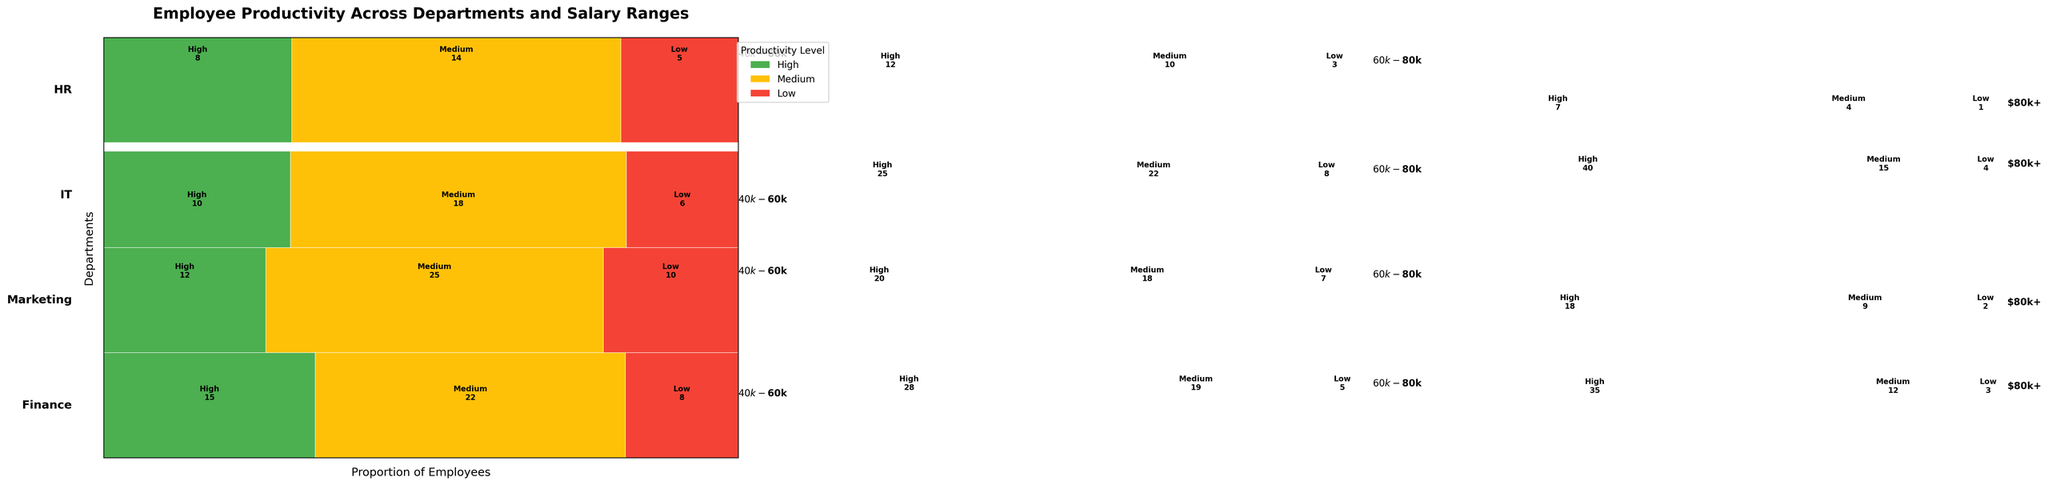What are the salary ranges displayed in the mosaic plot? The salary ranges are displayed as part of the labels within the plot for each department. One can directly refer to these labels for the information.
Answer: $40k-$60k, $60k-$80k, $80k+ Which department has the highest count of high productivity employees in the $60k-$80k range? To answer this, look at the $60k-$80k salary range across all departments and compare the size of the "High" productivity rectangles. The IT department has the largest rectangle for high productivity in this range.
Answer: IT In the Finance department, what productivity level has the lowest count in the $80k+ salary range? In the Finance department section, observe the $80k+ salary range. The smallest rectangle corresponds to the productivity level with the lowest count. It is the "Low" productivity level.
Answer: Low Comparing the HR and Marketing departments, which one has more medium productivity employees in the $40k-$60k salary range? By comparing the rectangles representing medium productivity in the $40k-$60k salary range between HR and Marketing, it is clear that Marketing has a larger rectangle.
Answer: Marketing What is the total number of high productivity employees in the IT department across all salary ranges? Add the counts of high productivity employees in the IT department for all salary ranges: $40k-$60k (10), $60k-$80k (25), $80k+ (40).
Answer: 75 Which department has the highest overall percentage of low productivity employees? Analyze the proportions of "Low" productivity rectangles across all departments. By summing up the visible proportions, the Finance department has the least sizeable low productivity rectangles.
Answer: Finance In the $80k+ salary range, which department has the smallest count of medium productivity employees? Look at the $80k+ salary range for each department and compare the size of the medium productivity rectangles. HR has the smallest rectangle for medium productivity in this range.
Answer: HR What proportion of high productivity employees are in the Marketing department for the $60k-$80k salary range? For the Marketing department in the $60k-$80k range, the count of high productivity employees is 20. Summing up all counts for this range (High: 20, Medium: 18, Low: 7) gives a total of 45. The proportion is 20/45.
Answer: ~0.444 (or 44.4%) How does the count of low productivity employees in the Finance department compare to those in IT across all salary ranges? Sum the counts of low productivity employees in Finance and IT departments across all salary ranges: Finance (8 + 5 + 3 = 16), IT (6 + 8 + 4 = 18).
Answer: IT has more low productivity employees Is the count of medium productivity employees in HR higher than that in Marketing for the $60k-$80k range? Compare the medium productivity rectangles in the $60k-$80k salary range for HR and Marketing, where HR has 10 and Marketing has 18.
Answer: No 